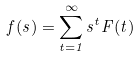<formula> <loc_0><loc_0><loc_500><loc_500>f ( s ) = \sum _ { t = 1 } ^ { \infty } s ^ { t } F ( t )</formula> 